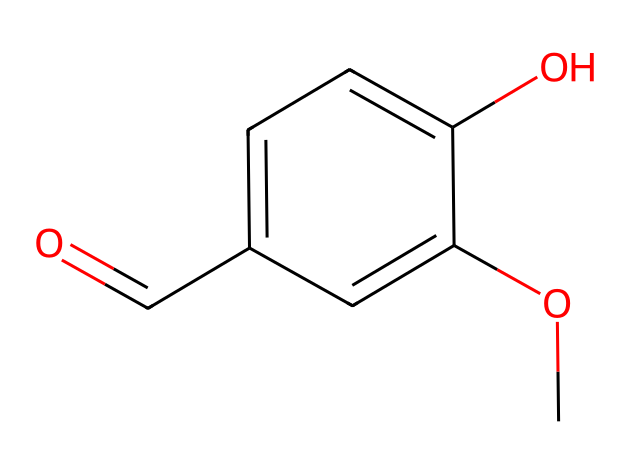How many carbon atoms are in vanillin? The SMILES notation indicates the presence of six 'C' symbols for carbon atoms in the backbone structure, confirming that there are six carbon atoms.
Answer: six What functional groups are present in vanillin? Examining the SMILES representation, we identify an ether (-O-) and aldehyde (-C=O) functional group, alongside the presence of a hydroxyl (-OH) group.
Answer: ether, aldehyde, hydroxyl How many hydrogen atoms are bonded to carbon in vanillin? Each carbon atom typically bonds with enough hydrogen atoms to fulfill the tetravalency of carbon. Given the structure, we can count that there are six hydrogen atoms based on the saturation of the molecule.
Answer: six What type of aromatic compound is represented by vanillin? The molecule exhibits a benzene ring structure, which is indicated by the presence of alternating double bonds in the structure, confirming that it is an aromatic compound.
Answer: aromatic What property of vanillin is likely influenced by its hydroxyl group? The presence of the hydroxyl group enhances its ability to form hydrogen bonds with water, thus influencing its solubility in polar solvents.
Answer: solubility Which stereochemical feature is absent in vanillin? The structure of vanillin does not include any chiral centers; thus, it is not a chiral molecule.
Answer: chiral centers 